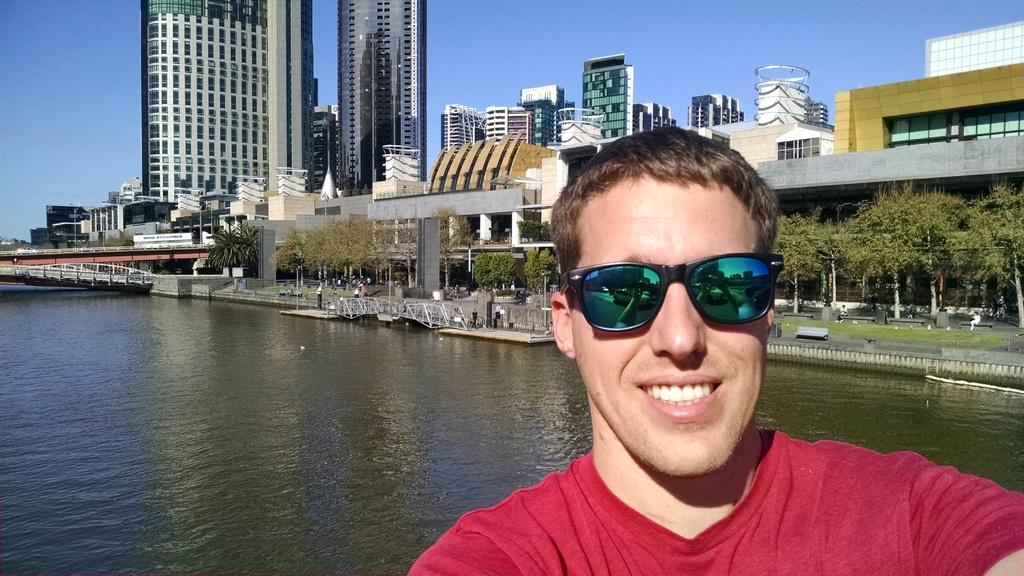What is the main subject of the image? There is a person in the image. What is the person wearing? The person is wearing a T-shirt and goggles. What can be seen in the background of the image? There are buildings, trees, benches, and a river visible in the image. What structures are present in the image? There is a bridge and poles in the image. What part of the natural environment is visible in the image? The sky is visible in the image. What type of feast is the person attending in the image? There is no indication of a feast or any gathering in the image. How many brothers does the person in the image have? There is no information about the person's family or siblings in the image. 